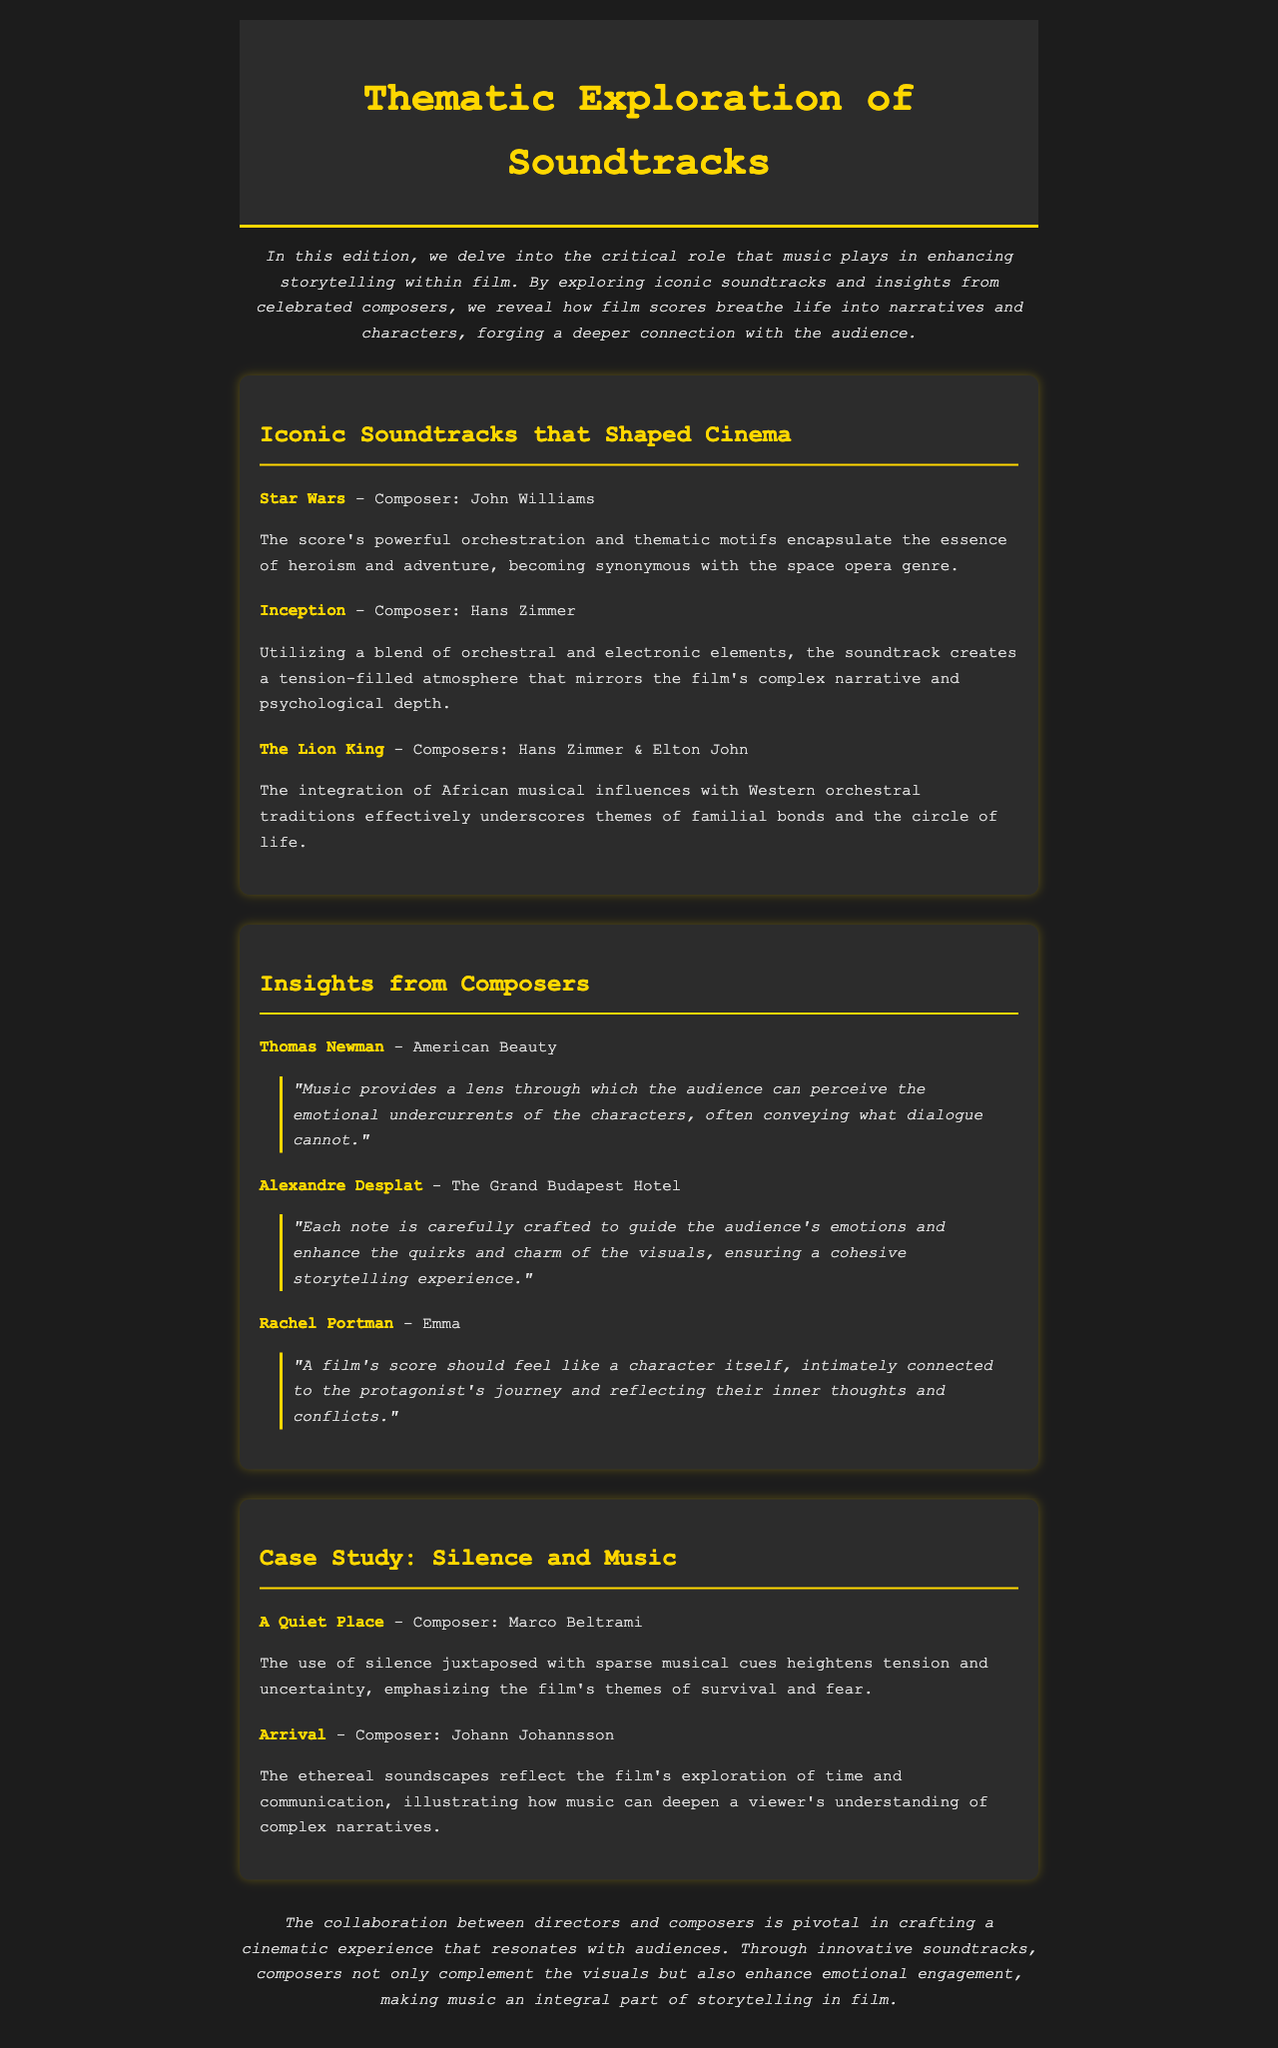What is the title of the newsletter? The title is prominently displayed at the top of the newsletter, signaling the focus of the content.
Answer: Thematic Exploration of Soundtracks Who composed the score for "Inception"? The composer for "Inception" is mentioned alongside the film title in the summary of iconic soundtracks.
Answer: Hans Zimmer Which film features music by both Hans Zimmer and Elton John? The film is noted for its dual-composer approach, highlighting the collaboration in the provided context.
Answer: The Lion King What emotion does Thomas Newman suggest music conveys in films? The quote indicates that music can express emotions that dialogue cannot, emphasizing its role in storytelling.
Answer: Emotional undercurrents What does Rachel Portman believe a film's score should represent? Portman's quote refers to the score's connection to the protagonist's journey and internal conflicts.
Answer: A character Which composer worked on the soundtrack for "A Quiet Place"? The specific composer is identified with the case study that examines the role of silence and music in the film's score.
Answer: Marco Beltrami How does Marco Beltrami's score affect the film "A Quiet Place"? The score's unique approach is analyzed in the context of the film's themes of survival and fear.
Answer: Heightens tension What does the newsletter suggest about the collaboration between directors and composers? The conclusion of the newsletter emphasizes the importance of teamwork in creating impactful cinema through soundtracks.
Answer: Pivotal What musical styles are blended in the score for "Inception"? The description highlights the specific musical elements that are combined to create the film's atmosphere.
Answer: Orchestral and electronic elements 